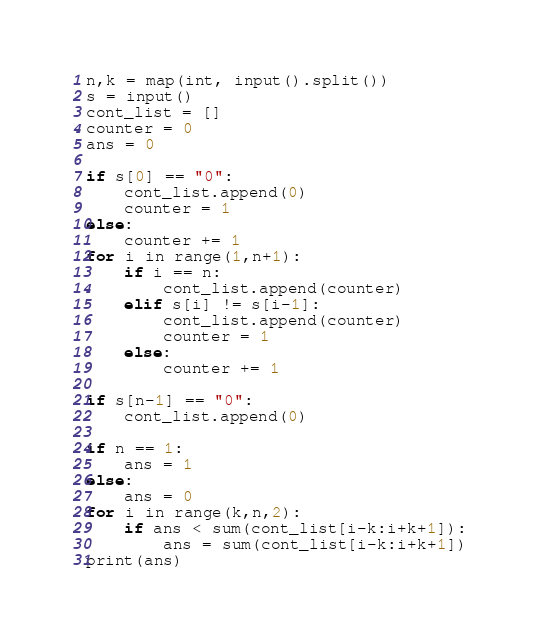<code> <loc_0><loc_0><loc_500><loc_500><_Python_>n,k = map(int, input().split())
s = input()
cont_list = []
counter = 0
ans = 0

if s[0] == "0":
    cont_list.append(0)
    counter = 1
else:
    counter += 1
for i in range(1,n+1):
    if i == n:
        cont_list.append(counter)
    elif s[i] != s[i-1]:
        cont_list.append(counter)
        counter = 1
    else:
        counter += 1

if s[n-1] == "0":
    cont_list.append(0)

if n == 1:
    ans = 1
else:
    ans = 0
for i in range(k,n,2):
    if ans < sum(cont_list[i-k:i+k+1]):
        ans = sum(cont_list[i-k:i+k+1])
print(ans)
</code> 